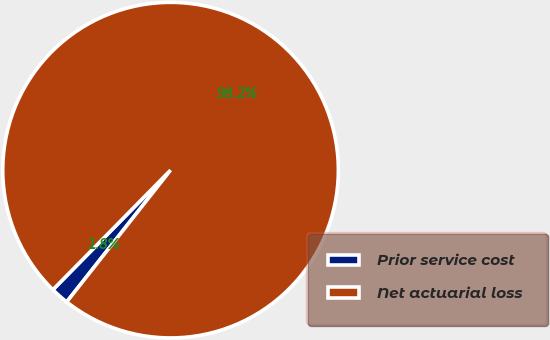<chart> <loc_0><loc_0><loc_500><loc_500><pie_chart><fcel>Prior service cost<fcel>Net actuarial loss<nl><fcel>1.75%<fcel>98.25%<nl></chart> 